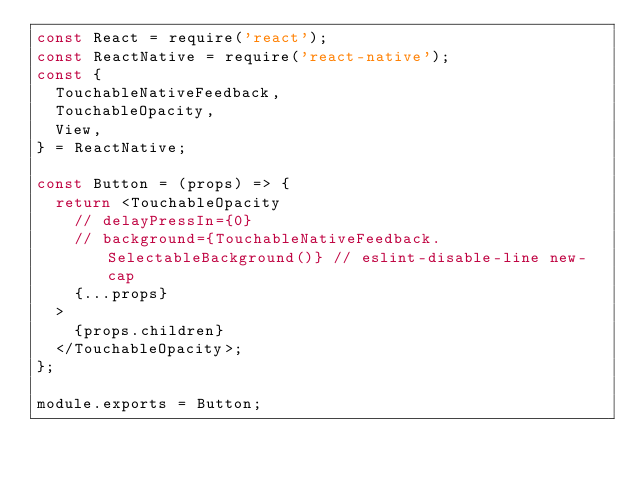Convert code to text. <code><loc_0><loc_0><loc_500><loc_500><_JavaScript_>const React = require('react');
const ReactNative = require('react-native');
const {
  TouchableNativeFeedback,
  TouchableOpacity,
  View,
} = ReactNative;

const Button = (props) => {
  return <TouchableOpacity
    // delayPressIn={0}
    // background={TouchableNativeFeedback.SelectableBackground()} // eslint-disable-line new-cap
    {...props}
  >
    {props.children}
  </TouchableOpacity>;
};

module.exports = Button;
</code> 